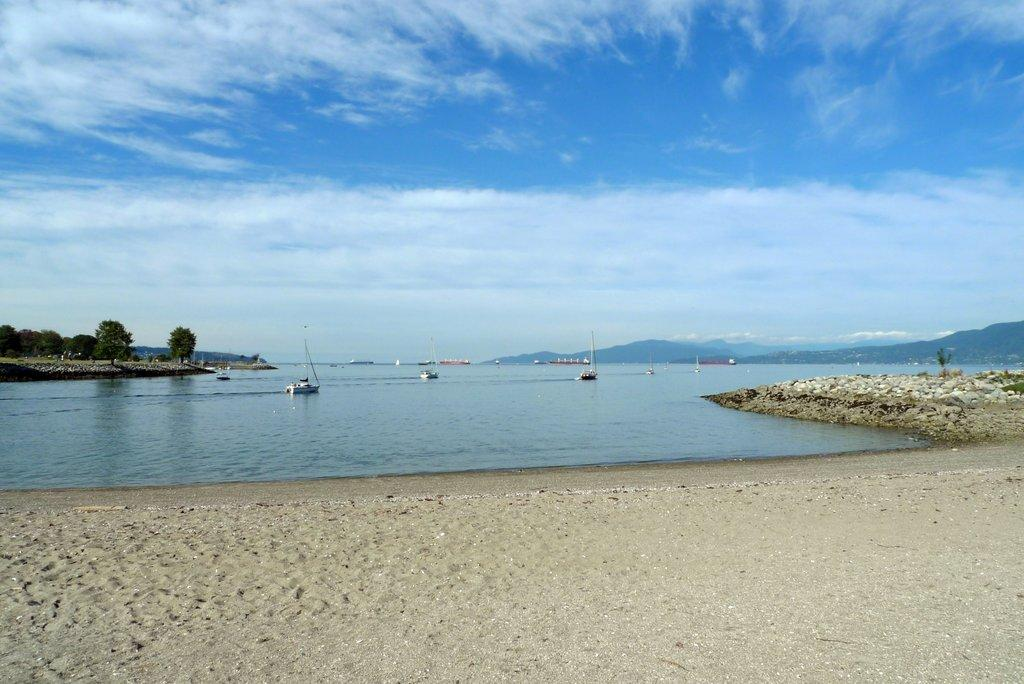What type of terrain is visible in the image? There is sand in the image. What can be seen on the water in the image? There are boats on the water in the image. What type of vegetation is in the background of the image? There are trees in the background of the image. What is visible at the top of the image? The sky is visible at the top of the image. What can be seen in the sky in the image? Clouds are present in the sky. What type of door can be seen in the image? There is no door present in the image. What disease is affecting the boats in the image? There is no disease affecting the boats in the image; they appear to be functioning normally. 